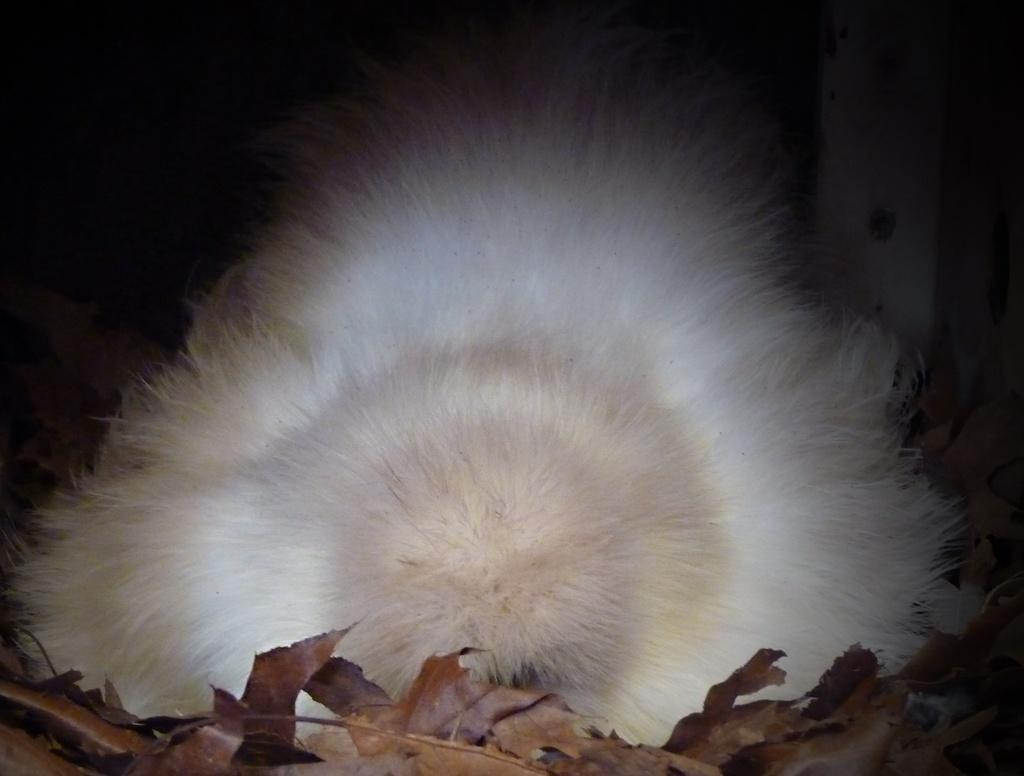What type of natural elements can be seen in the image? There are dry leaves in the image. What color is the prominent object in the image? The white color object is present in the image. How would you describe the overall lighting or color scheme of the image? The backdrop of the image is dark. What type of tray is being used by the skater at the station in the image? There is no tray, skater, or station present in the image. 